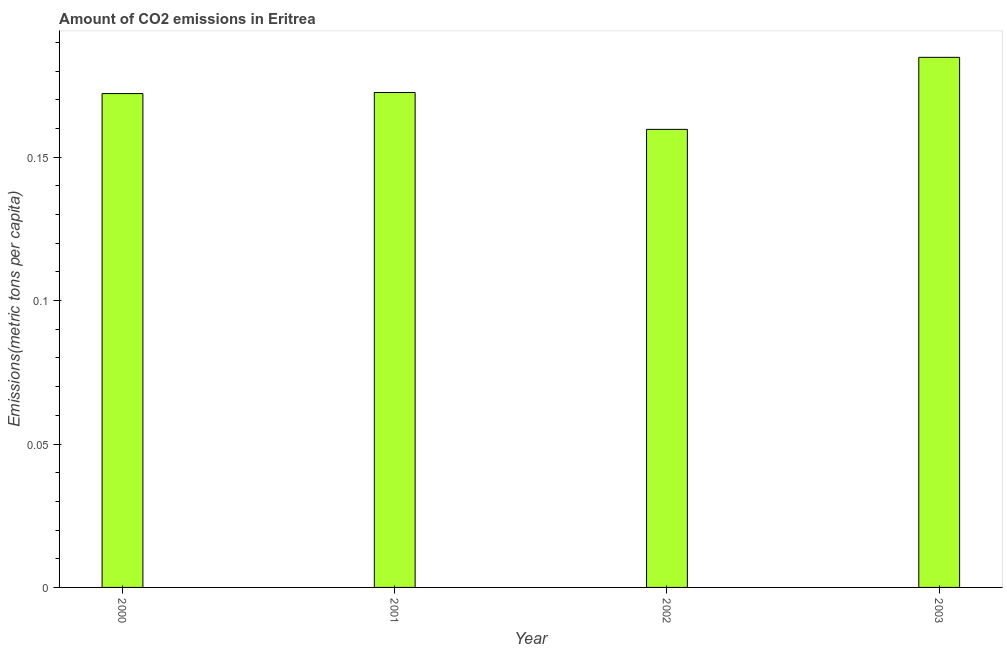Does the graph contain any zero values?
Make the answer very short. No. What is the title of the graph?
Offer a very short reply. Amount of CO2 emissions in Eritrea. What is the label or title of the Y-axis?
Your answer should be compact. Emissions(metric tons per capita). What is the amount of co2 emissions in 2001?
Offer a terse response. 0.17. Across all years, what is the maximum amount of co2 emissions?
Give a very brief answer. 0.18. Across all years, what is the minimum amount of co2 emissions?
Ensure brevity in your answer.  0.16. In which year was the amount of co2 emissions minimum?
Make the answer very short. 2002. What is the sum of the amount of co2 emissions?
Give a very brief answer. 0.69. What is the difference between the amount of co2 emissions in 2000 and 2002?
Ensure brevity in your answer.  0.01. What is the average amount of co2 emissions per year?
Provide a short and direct response. 0.17. What is the median amount of co2 emissions?
Ensure brevity in your answer.  0.17. What is the ratio of the amount of co2 emissions in 2002 to that in 2003?
Offer a very short reply. 0.86. What is the difference between the highest and the second highest amount of co2 emissions?
Offer a very short reply. 0.01. Is the sum of the amount of co2 emissions in 2000 and 2002 greater than the maximum amount of co2 emissions across all years?
Offer a terse response. Yes. What is the difference between the highest and the lowest amount of co2 emissions?
Offer a very short reply. 0.03. What is the difference between two consecutive major ticks on the Y-axis?
Your answer should be very brief. 0.05. What is the Emissions(metric tons per capita) in 2000?
Give a very brief answer. 0.17. What is the Emissions(metric tons per capita) in 2001?
Your answer should be compact. 0.17. What is the Emissions(metric tons per capita) in 2002?
Ensure brevity in your answer.  0.16. What is the Emissions(metric tons per capita) in 2003?
Offer a terse response. 0.18. What is the difference between the Emissions(metric tons per capita) in 2000 and 2001?
Offer a very short reply. -0. What is the difference between the Emissions(metric tons per capita) in 2000 and 2002?
Your answer should be very brief. 0.01. What is the difference between the Emissions(metric tons per capita) in 2000 and 2003?
Your answer should be compact. -0.01. What is the difference between the Emissions(metric tons per capita) in 2001 and 2002?
Your response must be concise. 0.01. What is the difference between the Emissions(metric tons per capita) in 2001 and 2003?
Your answer should be very brief. -0.01. What is the difference between the Emissions(metric tons per capita) in 2002 and 2003?
Ensure brevity in your answer.  -0.03. What is the ratio of the Emissions(metric tons per capita) in 2000 to that in 2002?
Provide a succinct answer. 1.08. What is the ratio of the Emissions(metric tons per capita) in 2000 to that in 2003?
Provide a short and direct response. 0.93. What is the ratio of the Emissions(metric tons per capita) in 2001 to that in 2002?
Provide a succinct answer. 1.08. What is the ratio of the Emissions(metric tons per capita) in 2001 to that in 2003?
Ensure brevity in your answer.  0.93. What is the ratio of the Emissions(metric tons per capita) in 2002 to that in 2003?
Offer a terse response. 0.86. 